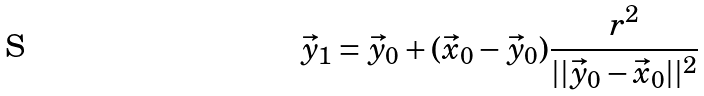Convert formula to latex. <formula><loc_0><loc_0><loc_500><loc_500>\vec { y } _ { 1 } = \vec { y } _ { 0 } + ( \vec { x } _ { 0 } - \vec { y } _ { 0 } ) \frac { r ^ { 2 } } { | | \vec { y } _ { 0 } - \vec { x } _ { 0 } | | ^ { 2 } }</formula> 